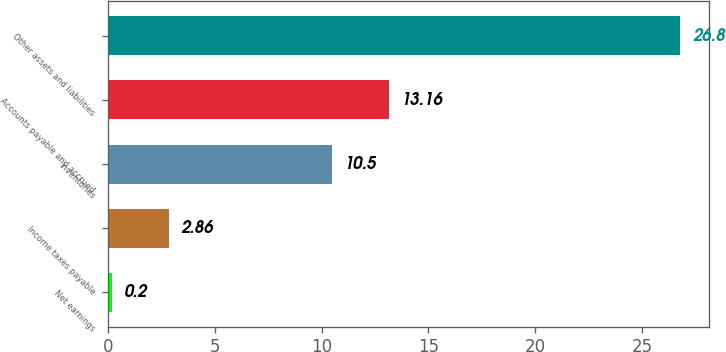Convert chart to OTSL. <chart><loc_0><loc_0><loc_500><loc_500><bar_chart><fcel>Net earnings<fcel>Income taxes payable<fcel>Inventories<fcel>Accounts payable and accrued<fcel>Other assets and liabilities<nl><fcel>0.2<fcel>2.86<fcel>10.5<fcel>13.16<fcel>26.8<nl></chart> 